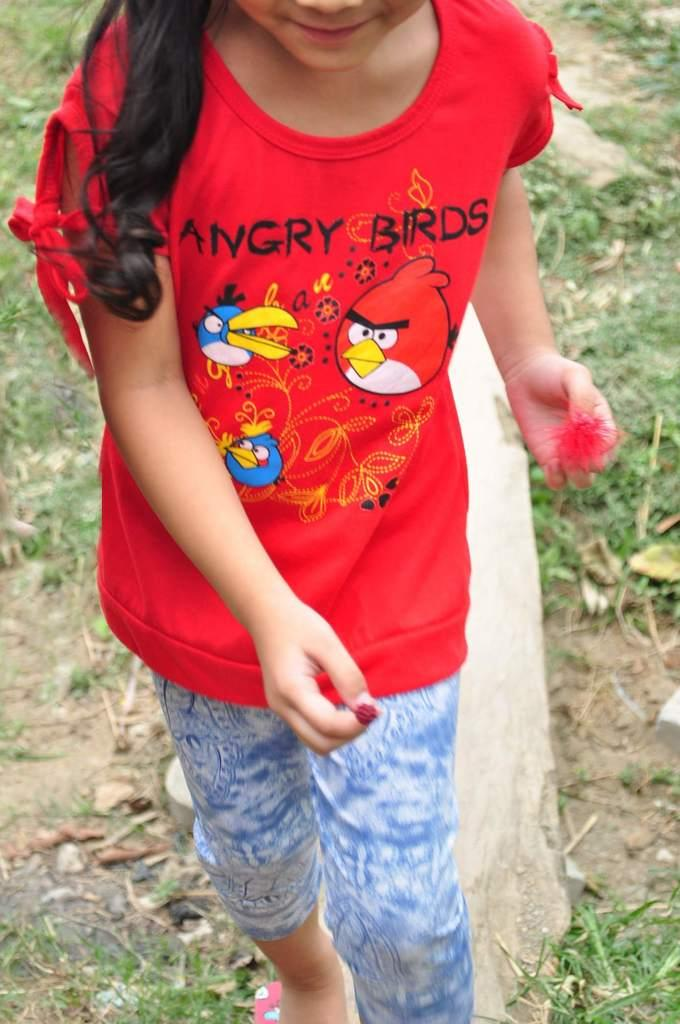What is present in the image? There is a person in the image. Can you describe the person's clothing? The person is wearing a dress with red, blue, and white colors. What can be seen in the background of the image? There is grass and dry leaves visible in the background. How much tax does the tiger have to pay in the image? There is no tiger present in the image, and therefore no tax-related information can be determined. 